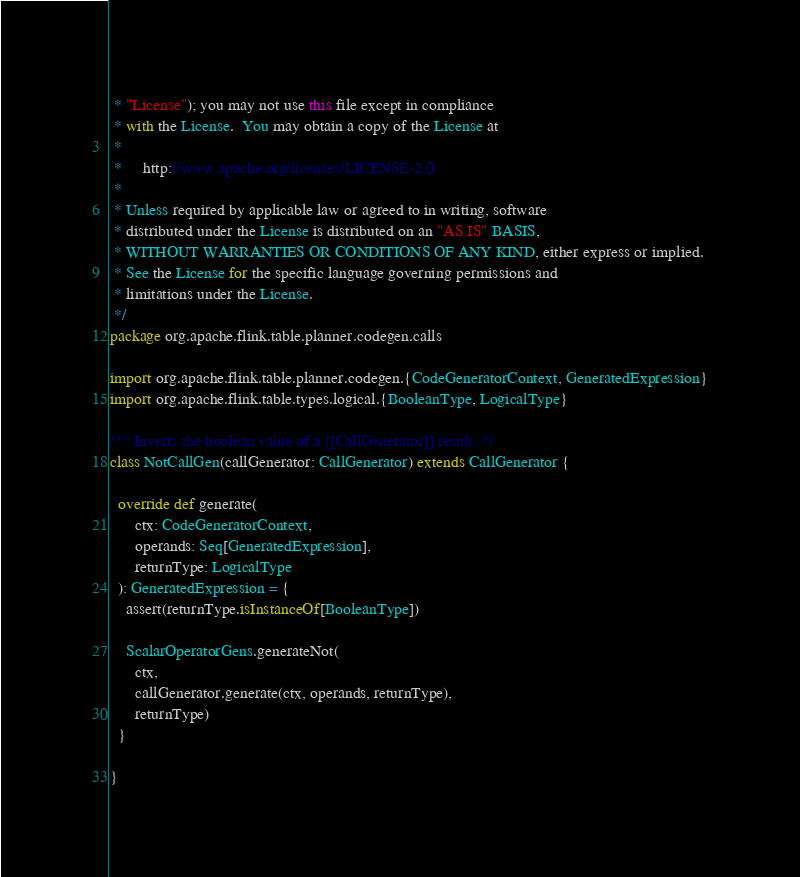Convert code to text. <code><loc_0><loc_0><loc_500><loc_500><_Scala_> * "License"); you may not use this file except in compliance
 * with the License.  You may obtain a copy of the License at
 *
 *     http://www.apache.org/licenses/LICENSE-2.0
 *
 * Unless required by applicable law or agreed to in writing, software
 * distributed under the License is distributed on an "AS IS" BASIS,
 * WITHOUT WARRANTIES OR CONDITIONS OF ANY KIND, either express or implied.
 * See the License for the specific language governing permissions and
 * limitations under the License.
 */
package org.apache.flink.table.planner.codegen.calls

import org.apache.flink.table.planner.codegen.{CodeGeneratorContext, GeneratedExpression}
import org.apache.flink.table.types.logical.{BooleanType, LogicalType}

/** Inverts the boolean value of a [[CallGenerator]] result. */
class NotCallGen(callGenerator: CallGenerator) extends CallGenerator {

  override def generate(
      ctx: CodeGeneratorContext,
      operands: Seq[GeneratedExpression],
      returnType: LogicalType
  ): GeneratedExpression = {
    assert(returnType.isInstanceOf[BooleanType])

    ScalarOperatorGens.generateNot(
      ctx,
      callGenerator.generate(ctx, operands, returnType),
      returnType)
  }

}
</code> 